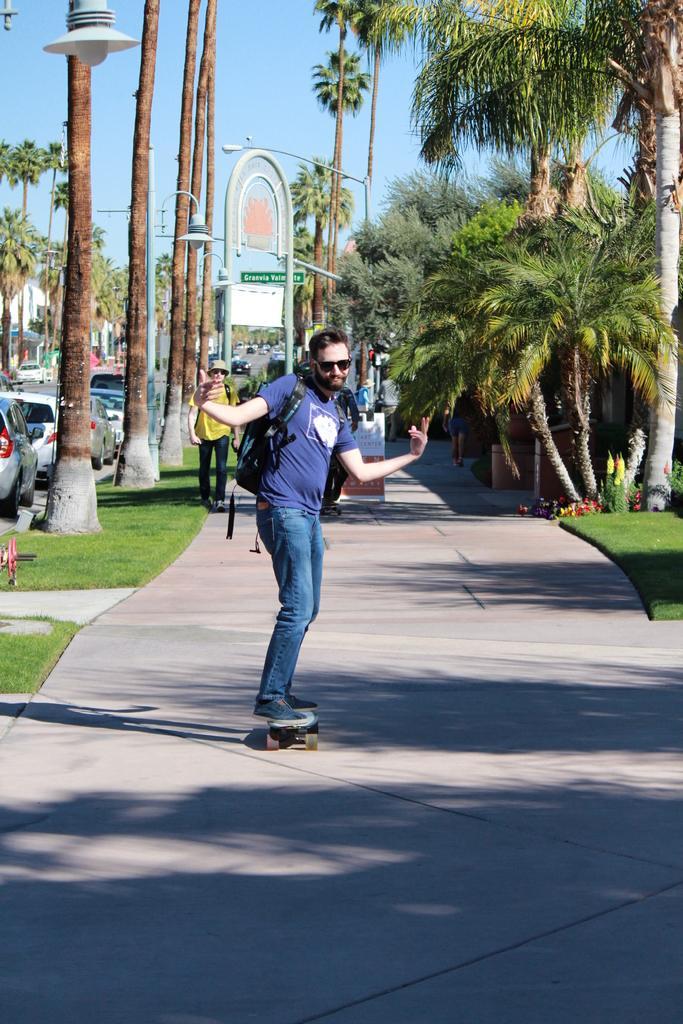In one or two sentences, can you explain what this image depicts? In the foreground of the picture I can see a man skating on the side road. He is wearing a T-shirt and he is carrying a bag on his back. I can see the trees on the left side and the right side as well. There are cars on the road. I can see the light poles on the side of the road. There is another man walking on the side of the road. 